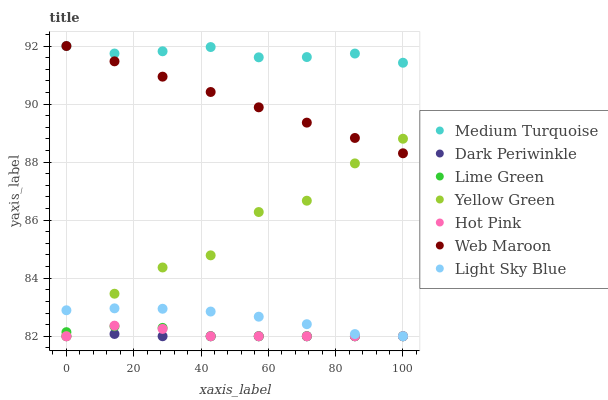Does Dark Periwinkle have the minimum area under the curve?
Answer yes or no. Yes. Does Medium Turquoise have the maximum area under the curve?
Answer yes or no. Yes. Does Hot Pink have the minimum area under the curve?
Answer yes or no. No. Does Hot Pink have the maximum area under the curve?
Answer yes or no. No. Is Web Maroon the smoothest?
Answer yes or no. Yes. Is Yellow Green the roughest?
Answer yes or no. Yes. Is Hot Pink the smoothest?
Answer yes or no. No. Is Hot Pink the roughest?
Answer yes or no. No. Does Yellow Green have the lowest value?
Answer yes or no. Yes. Does Web Maroon have the lowest value?
Answer yes or no. No. Does Medium Turquoise have the highest value?
Answer yes or no. Yes. Does Hot Pink have the highest value?
Answer yes or no. No. Is Dark Periwinkle less than Medium Turquoise?
Answer yes or no. Yes. Is Web Maroon greater than Light Sky Blue?
Answer yes or no. Yes. Does Web Maroon intersect Medium Turquoise?
Answer yes or no. Yes. Is Web Maroon less than Medium Turquoise?
Answer yes or no. No. Is Web Maroon greater than Medium Turquoise?
Answer yes or no. No. Does Dark Periwinkle intersect Medium Turquoise?
Answer yes or no. No. 